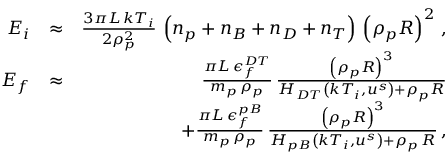Convert formula to latex. <formula><loc_0><loc_0><loc_500><loc_500>\begin{array} { r l r } { E _ { i } } & { \approx } & { \frac { 3 \pi L \, k T _ { i } } { 2 \rho _ { p } ^ { 2 } } \, \left ( n _ { p } + n _ { B } + n _ { D } + n _ { T } \right ) \, \left ( \rho _ { p } R \right ) ^ { 2 } \, , } \\ { E _ { f } } & { \approx } & { \frac { \pi L \, \epsilon _ { f } ^ { D T } } { m _ { p } \, \rho _ { p } } \, \frac { \left ( \rho _ { p } R \right ) ^ { 3 } } { H _ { D T } \left ( k T _ { i } , u ^ { s } \right ) + \rho _ { p } R } } \\ & { + \frac { \pi L \, \epsilon _ { f } ^ { p B } } { m _ { p } \, \rho _ { p } } \, \frac { \left ( \rho _ { p } R \right ) ^ { 3 } } { H _ { p B } \left ( k T _ { i } , u ^ { s } \right ) + \rho _ { p } \, R } \, , } \end{array}</formula> 